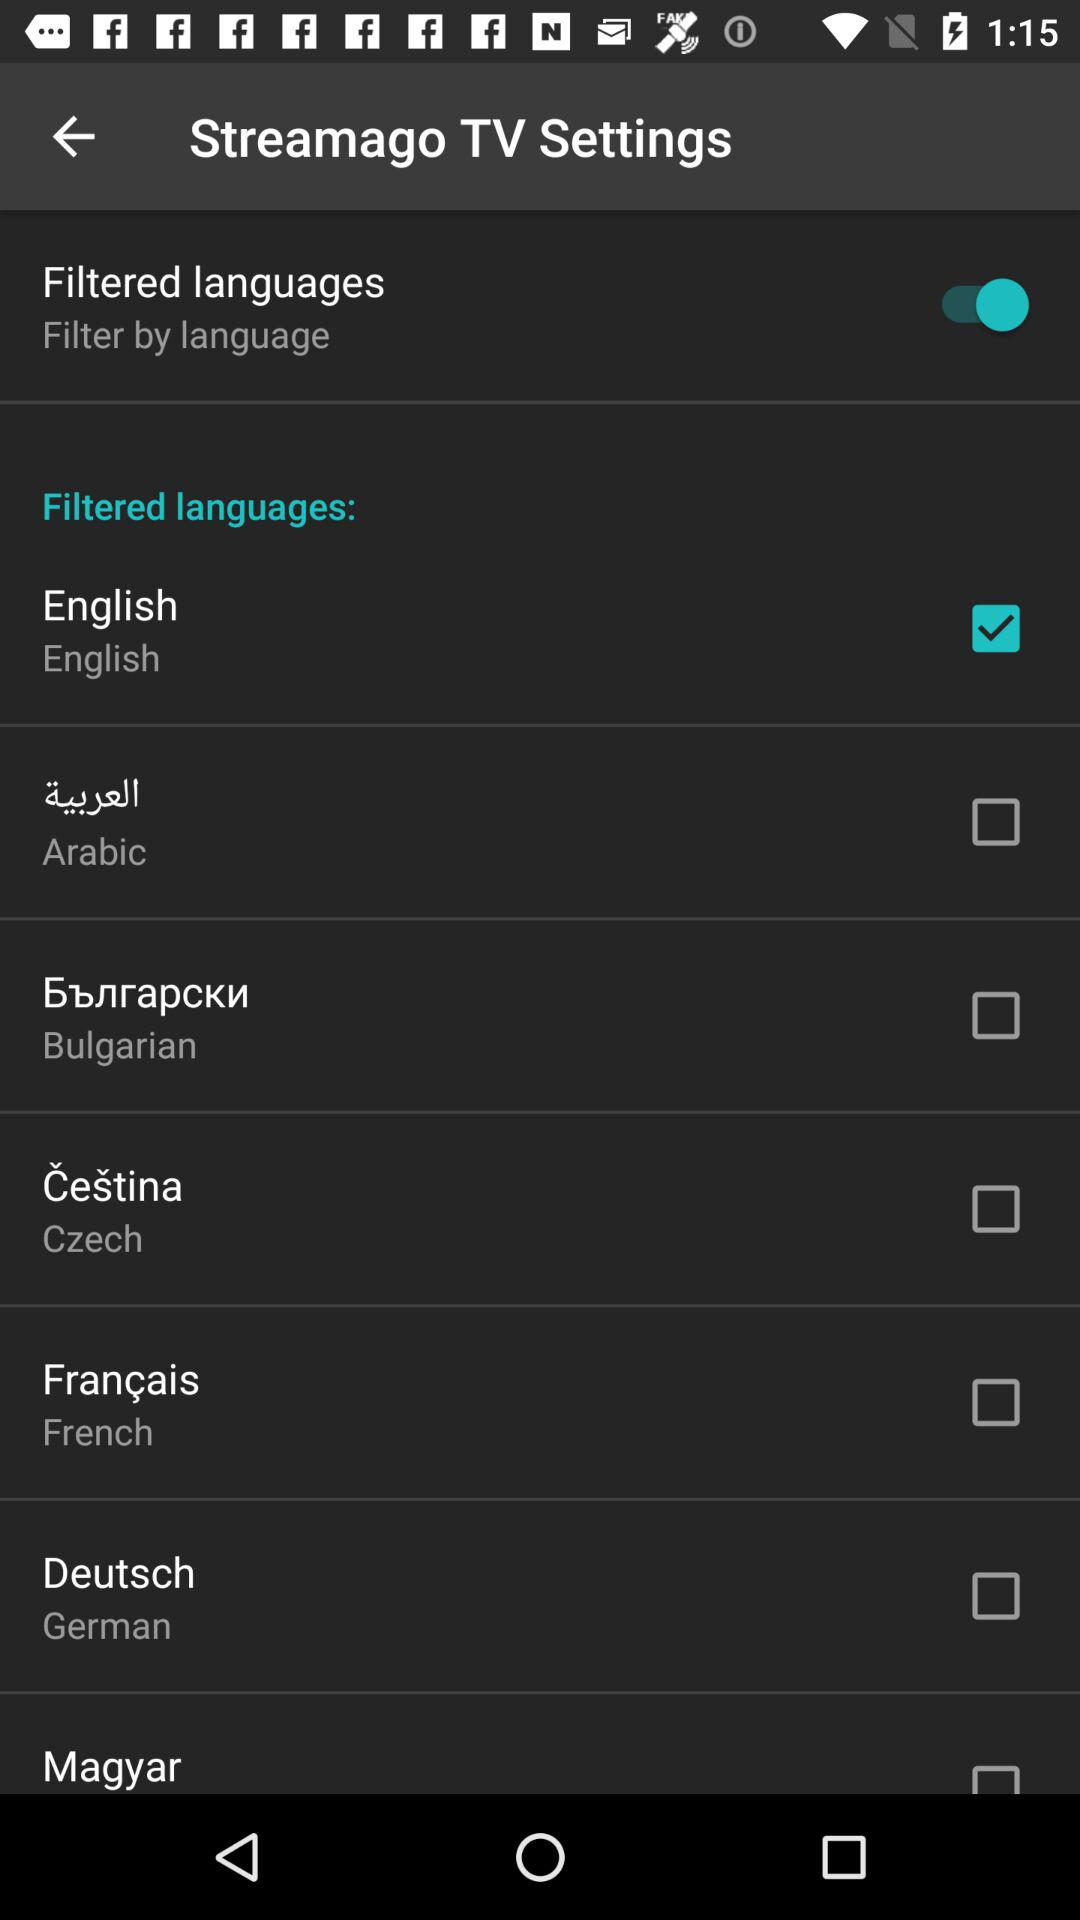What is the status of filtered language? The status is on. 